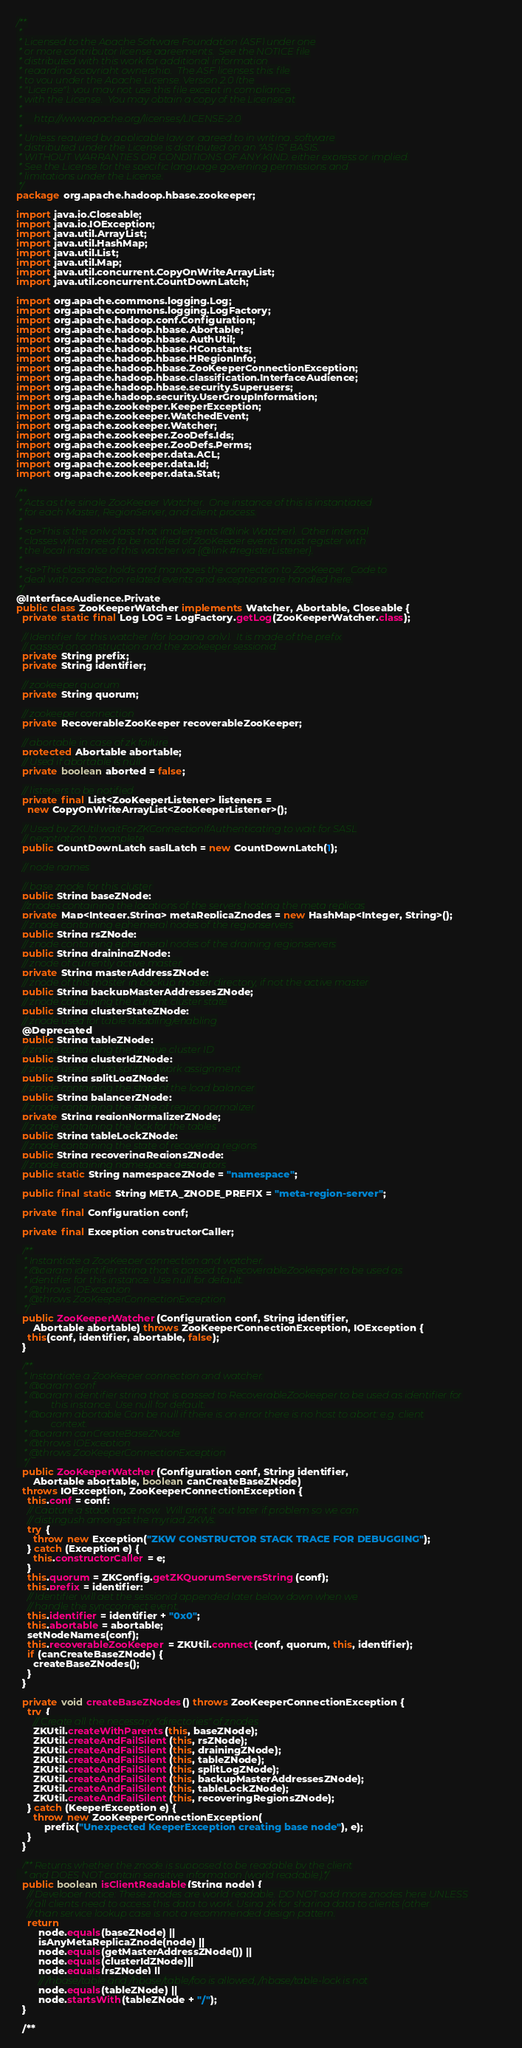<code> <loc_0><loc_0><loc_500><loc_500><_Java_>/**
 *
 * Licensed to the Apache Software Foundation (ASF) under one
 * or more contributor license agreements.  See the NOTICE file
 * distributed with this work for additional information
 * regarding copyright ownership.  The ASF licenses this file
 * to you under the Apache License, Version 2.0 (the
 * "License"); you may not use this file except in compliance
 * with the License.  You may obtain a copy of the License at
 *
 *     http://www.apache.org/licenses/LICENSE-2.0
 *
 * Unless required by applicable law or agreed to in writing, software
 * distributed under the License is distributed on an "AS IS" BASIS,
 * WITHOUT WARRANTIES OR CONDITIONS OF ANY KIND, either express or implied.
 * See the License for the specific language governing permissions and
 * limitations under the License.
 */
package org.apache.hadoop.hbase.zookeeper;

import java.io.Closeable;
import java.io.IOException;
import java.util.ArrayList;
import java.util.HashMap;
import java.util.List;
import java.util.Map;
import java.util.concurrent.CopyOnWriteArrayList;
import java.util.concurrent.CountDownLatch;

import org.apache.commons.logging.Log;
import org.apache.commons.logging.LogFactory;
import org.apache.hadoop.conf.Configuration;
import org.apache.hadoop.hbase.Abortable;
import org.apache.hadoop.hbase.AuthUtil;
import org.apache.hadoop.hbase.HConstants;
import org.apache.hadoop.hbase.HRegionInfo;
import org.apache.hadoop.hbase.ZooKeeperConnectionException;
import org.apache.hadoop.hbase.classification.InterfaceAudience;
import org.apache.hadoop.hbase.security.Superusers;
import org.apache.hadoop.security.UserGroupInformation;
import org.apache.zookeeper.KeeperException;
import org.apache.zookeeper.WatchedEvent;
import org.apache.zookeeper.Watcher;
import org.apache.zookeeper.ZooDefs.Ids;
import org.apache.zookeeper.ZooDefs.Perms;
import org.apache.zookeeper.data.ACL;
import org.apache.zookeeper.data.Id;
import org.apache.zookeeper.data.Stat;

/**
 * Acts as the single ZooKeeper Watcher.  One instance of this is instantiated
 * for each Master, RegionServer, and client process.
 *
 * <p>This is the only class that implements {@link Watcher}.  Other internal
 * classes which need to be notified of ZooKeeper events must register with
 * the local instance of this watcher via {@link #registerListener}.
 *
 * <p>This class also holds and manages the connection to ZooKeeper.  Code to
 * deal with connection related events and exceptions are handled here.
 */
@InterfaceAudience.Private
public class ZooKeeperWatcher implements Watcher, Abortable, Closeable {
  private static final Log LOG = LogFactory.getLog(ZooKeeperWatcher.class);

  // Identifier for this watcher (for logging only).  It is made of the prefix
  // passed on construction and the zookeeper sessionid.
  private String prefix;
  private String identifier;

  // zookeeper quorum
  private String quorum;

  // zookeeper connection
  private RecoverableZooKeeper recoverableZooKeeper;

  // abortable in case of zk failure
  protected Abortable abortable;
  // Used if abortable is null
  private boolean aborted = false;

  // listeners to be notified
  private final List<ZooKeeperListener> listeners =
    new CopyOnWriteArrayList<ZooKeeperListener>();

  // Used by ZKUtil:waitForZKConnectionIfAuthenticating to wait for SASL
  // negotiation to complete
  public CountDownLatch saslLatch = new CountDownLatch(1);

  // node names

  // base znode for this cluster
  public String baseZNode;
  //znodes containing the locations of the servers hosting the meta replicas
  private Map<Integer,String> metaReplicaZnodes = new HashMap<Integer, String>();
  // znode containing ephemeral nodes of the regionservers
  public String rsZNode;
  // znode containing ephemeral nodes of the draining regionservers
  public String drainingZNode;
  // znode of currently active master
  private String masterAddressZNode;
  // znode of this master in backup master directory, if not the active master
  public String backupMasterAddressesZNode;
  // znode containing the current cluster state
  public String clusterStateZNode;
  // znode used for table disabling/enabling
  @Deprecated
  public String tableZNode;
  // znode containing the unique cluster ID
  public String clusterIdZNode;
  // znode used for log splitting work assignment
  public String splitLogZNode;
  // znode containing the state of the load balancer
  public String balancerZNode;
  // znode containing the state of region normalizer
  private String regionNormalizerZNode;
  // znode containing the lock for the tables
  public String tableLockZNode;
  // znode containing the state of recovering regions
  public String recoveringRegionsZNode;
  // znode containing namespace descriptors
  public static String namespaceZNode = "namespace";

  public final static String META_ZNODE_PREFIX = "meta-region-server";

  private final Configuration conf;

  private final Exception constructorCaller;

  /**
   * Instantiate a ZooKeeper connection and watcher.
   * @param identifier string that is passed to RecoverableZookeeper to be used as
   * identifier for this instance. Use null for default.
   * @throws IOException
   * @throws ZooKeeperConnectionException
   */
  public ZooKeeperWatcher(Configuration conf, String identifier,
      Abortable abortable) throws ZooKeeperConnectionException, IOException {
    this(conf, identifier, abortable, false);
  }

  /**
   * Instantiate a ZooKeeper connection and watcher.
   * @param conf
   * @param identifier string that is passed to RecoverableZookeeper to be used as identifier for
   *          this instance. Use null for default.
   * @param abortable Can be null if there is on error there is no host to abort: e.g. client
   *          context.
   * @param canCreateBaseZNode
   * @throws IOException
   * @throws ZooKeeperConnectionException
   */
  public ZooKeeperWatcher(Configuration conf, String identifier,
      Abortable abortable, boolean canCreateBaseZNode)
  throws IOException, ZooKeeperConnectionException {
    this.conf = conf;
    // Capture a stack trace now.  Will print it out later if problem so we can
    // distingush amongst the myriad ZKWs.
    try {
      throw new Exception("ZKW CONSTRUCTOR STACK TRACE FOR DEBUGGING");
    } catch (Exception e) {
      this.constructorCaller = e;
    }
    this.quorum = ZKConfig.getZKQuorumServersString(conf);
    this.prefix = identifier;
    // Identifier will get the sessionid appended later below down when we
    // handle the syncconnect event.
    this.identifier = identifier + "0x0";
    this.abortable = abortable;
    setNodeNames(conf);
    this.recoverableZooKeeper = ZKUtil.connect(conf, quorum, this, identifier);
    if (canCreateBaseZNode) {
      createBaseZNodes();
    }
  }

  private void createBaseZNodes() throws ZooKeeperConnectionException {
    try {
      // Create all the necessary "directories" of znodes
      ZKUtil.createWithParents(this, baseZNode);
      ZKUtil.createAndFailSilent(this, rsZNode);
      ZKUtil.createAndFailSilent(this, drainingZNode);
      ZKUtil.createAndFailSilent(this, tableZNode);
      ZKUtil.createAndFailSilent(this, splitLogZNode);
      ZKUtil.createAndFailSilent(this, backupMasterAddressesZNode);
      ZKUtil.createAndFailSilent(this, tableLockZNode);
      ZKUtil.createAndFailSilent(this, recoveringRegionsZNode);
    } catch (KeeperException e) {
      throw new ZooKeeperConnectionException(
          prefix("Unexpected KeeperException creating base node"), e);
    }
  }

  /** Returns whether the znode is supposed to be readable by the client
   * and DOES NOT contain sensitive information (world readable).*/
  public boolean isClientReadable(String node) {
    // Developer notice: These znodes are world readable. DO NOT add more znodes here UNLESS
    // all clients need to access this data to work. Using zk for sharing data to clients (other
    // than service lookup case is not a recommended design pattern.
    return
        node.equals(baseZNode) ||
        isAnyMetaReplicaZnode(node) ||
        node.equals(getMasterAddressZNode()) ||
        node.equals(clusterIdZNode)||
        node.equals(rsZNode) ||
        // /hbase/table and /hbase/table/foo is allowed, /hbase/table-lock is not
        node.equals(tableZNode) ||
        node.startsWith(tableZNode + "/");
  }

  /**</code> 